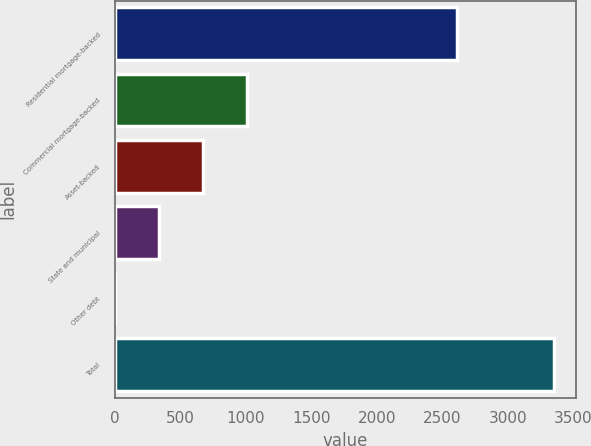<chart> <loc_0><loc_0><loc_500><loc_500><bar_chart><fcel>Residential mortgage-backed<fcel>Commercial mortgage-backed<fcel>Asset-backed<fcel>State and municipal<fcel>Other debt<fcel>Total<nl><fcel>2608<fcel>1008.7<fcel>673.8<fcel>338.9<fcel>4<fcel>3353<nl></chart> 